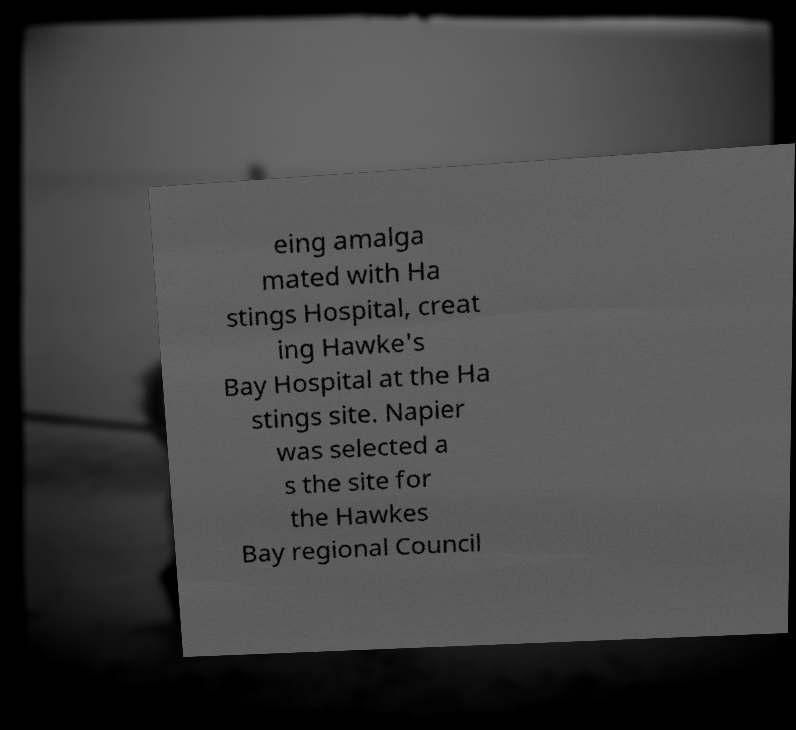Can you accurately transcribe the text from the provided image for me? eing amalga mated with Ha stings Hospital, creat ing Hawke's Bay Hospital at the Ha stings site. Napier was selected a s the site for the Hawkes Bay regional Council 